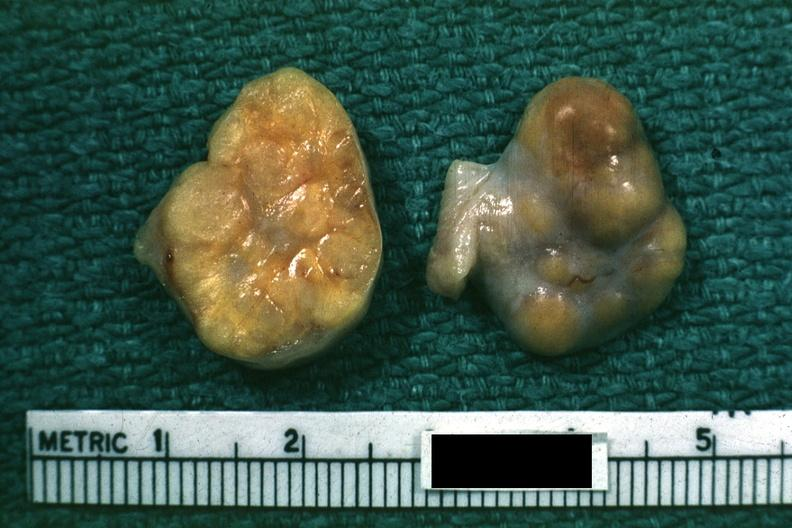what is present?
Answer the question using a single word or phrase. Female reproductive 